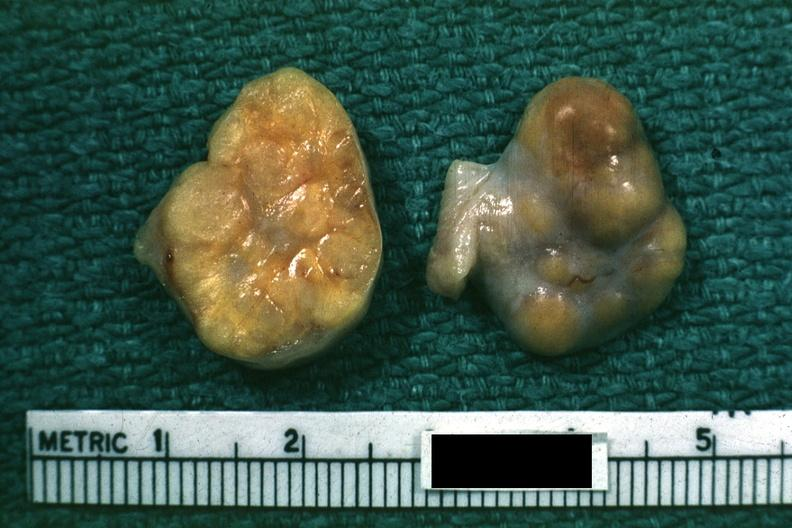what is present?
Answer the question using a single word or phrase. Female reproductive 